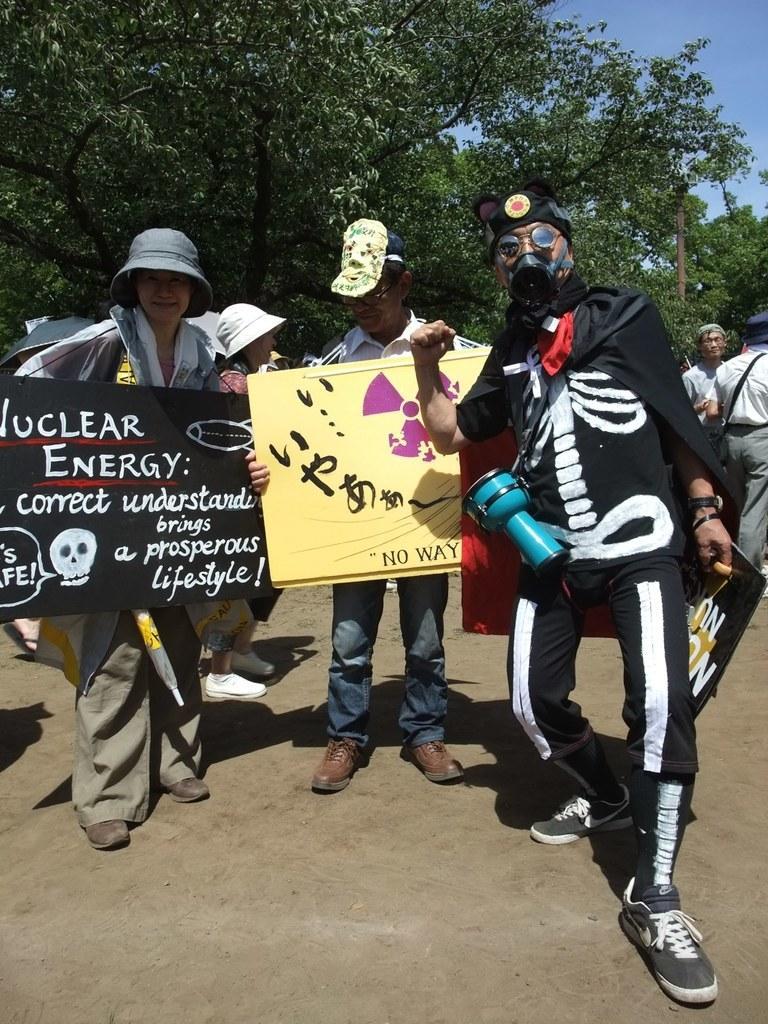Can you describe this image briefly? In this picture we can see a group of people on the ground, some people are holding posters and in the background we can see trees, pole, sky. 